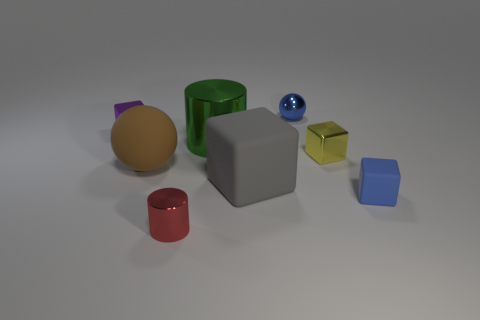Subtract all large rubber blocks. How many blocks are left? 3 Subtract all cylinders. How many objects are left? 6 Add 2 large gray things. How many objects exist? 10 Subtract all blue spheres. How many spheres are left? 1 Subtract 1 balls. How many balls are left? 1 Subtract all blue cubes. Subtract all green balls. How many cubes are left? 3 Subtract all green cylinders. How many cyan spheres are left? 0 Subtract all red cylinders. Subtract all large cubes. How many objects are left? 6 Add 7 small cylinders. How many small cylinders are left? 8 Add 7 blue metallic spheres. How many blue metallic spheres exist? 8 